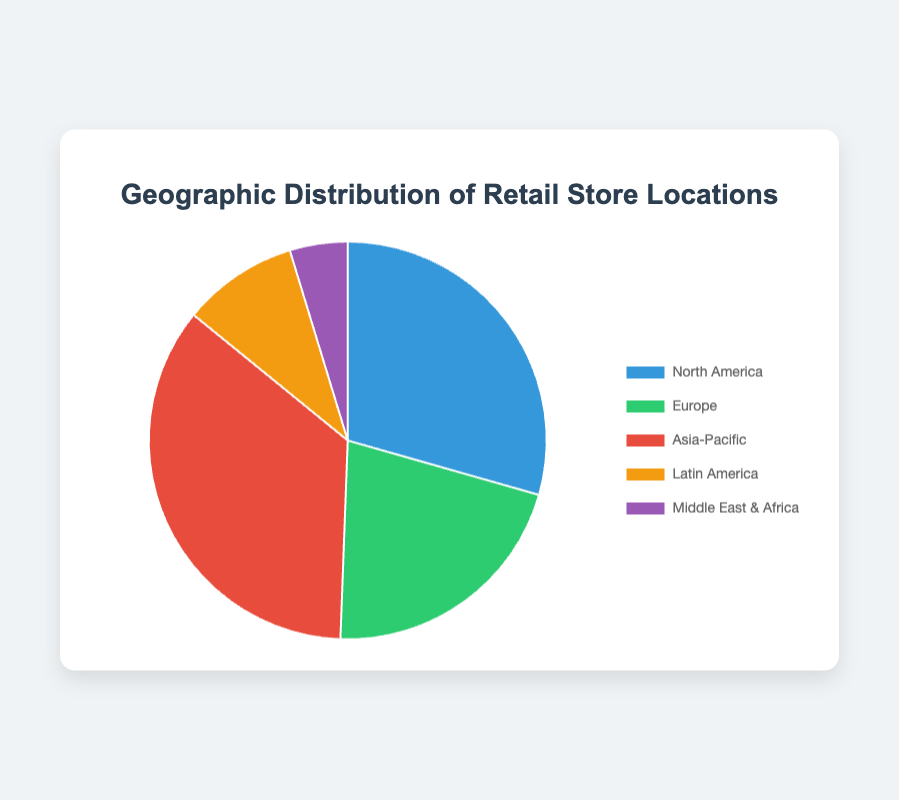Which region has the highest number of retail store locations? The slice representing Asia-Pacific is the largest in the pie chart, indicating it has the highest number of retail store locations.
Answer: Asia-Pacific Which region has fewer retail store locations, Europe or Latin America? By comparing the sizes of the slices, the one for Latin America is smaller than Europe. Hence, Latin America has fewer retail store locations.
Answer: Latin America What is the combined proportion of retail store locations in North America and Europe? First, add the number of locations in North America (2500) and Europe (1800) to get 4300. Then, find the total number of locations: 2500 + 1800 + 3000 + 800 + 400 = 8500. The combined proportion is 4300 / 8500.
Answer: 50.6% Which regions have more retail store locations than Latin America? Compare the number of locations: Latin America has 800 locations. Both North America (2500), Europe (1800), and Asia-Pacific (3000) have more locations than Latin America.
Answer: North America, Europe, Asia-Pacific Between the Middle East & Africa and Latin America, which region has a larger share, and by how much? Latin America has 800 locations and the Middle East & Africa has 400 locations. The difference is 800 - 400.
Answer: Latin America by 400 What percentage of total locations does the Asia-Pacific region hold? Asia-Pacific has 3000 locations. The total number of locations is 8500. Divide Asia-Pacific's locations by the total number and multiply by 100 to get the percentage: (3000 / 8500) * 100.
Answer: 35.3% How many more locations are there in North America compared to Europe? North America has 2500 locations, and Europe has 1800. Subtract Europe’s locations from North America’s: 2500 - 1800.
Answer: 700 Rank the regions from the highest to the lowest number of retail store locations. List the regions in descending order of their numbers: Asia-Pacific (3000), North America (2500), Europe (1800), Latin America (800), Middle East & Africa (400).
Answer: Asia-Pacific, North America, Europe, Latin America, Middle East & Africa Which regions together contribute to less than 10% of the total retail store locations? First, find 10% of the total locations: 8500 * 0.10 = 850. The Middle East & Africa has 400 locations. Only the Middle East & Africa contributes less than 850 locations.
Answer: Middle East & Africa 